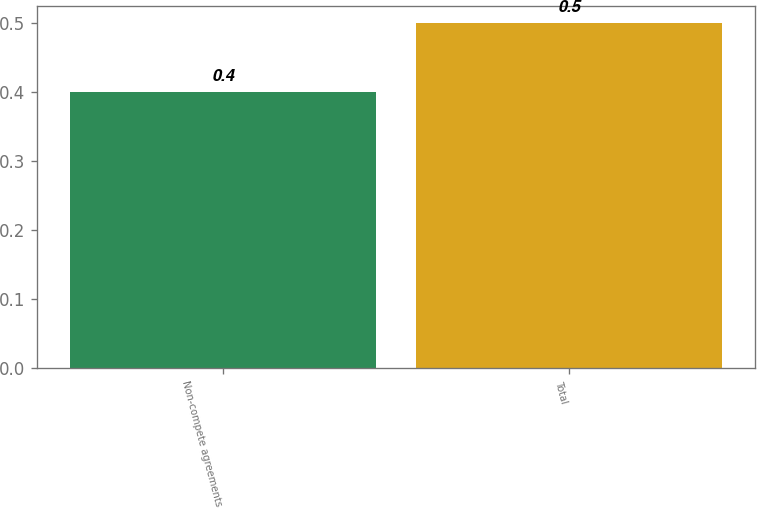<chart> <loc_0><loc_0><loc_500><loc_500><bar_chart><fcel>Non-compete agreements<fcel>Total<nl><fcel>0.4<fcel>0.5<nl></chart> 